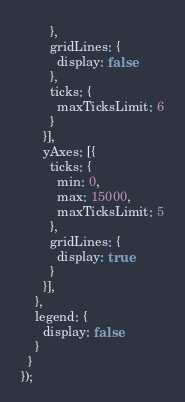<code> <loc_0><loc_0><loc_500><loc_500><_JavaScript_>        },
        gridLines: {
          display: false
        },
        ticks: {
          maxTicksLimit: 6
        }
      }],
      yAxes: [{
        ticks: {
          min: 0,
          max: 15000,
          maxTicksLimit: 5
        },
        gridLines: {
          display: true
        }
      }],
    },
    legend: {
      display: false
    }
  }
});</code> 